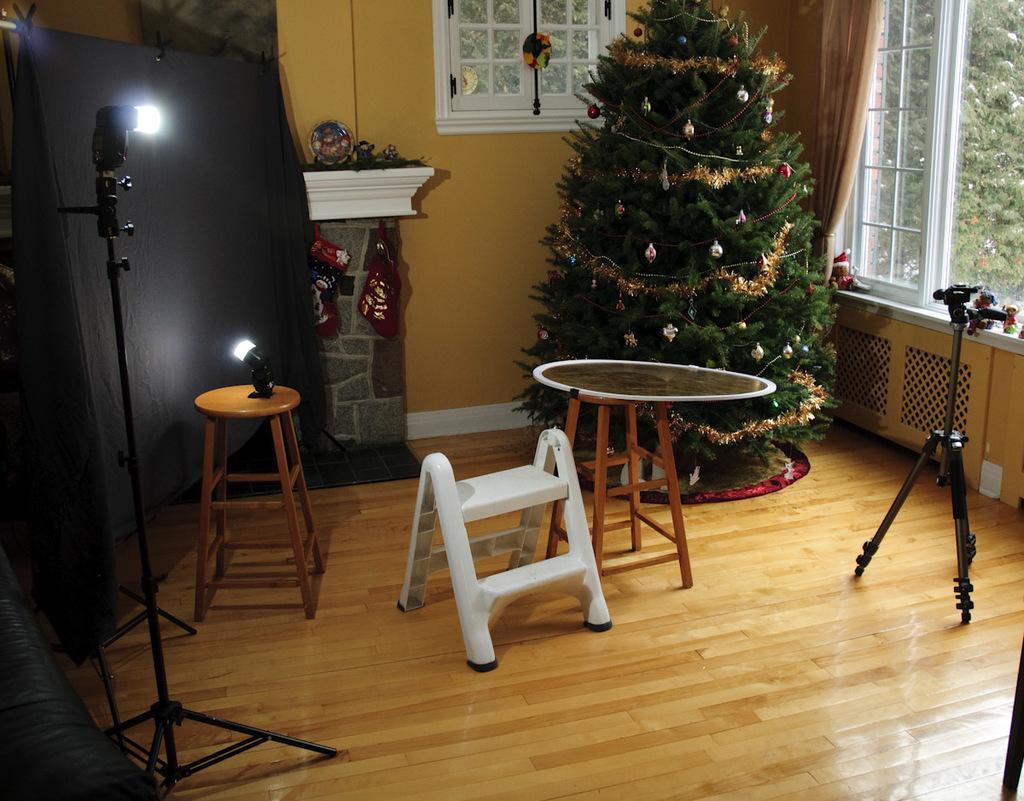In one or two sentences, can you explain what this image depicts? In this image i can see a table, a stool, a Christmas tree and other objects on the floor. 